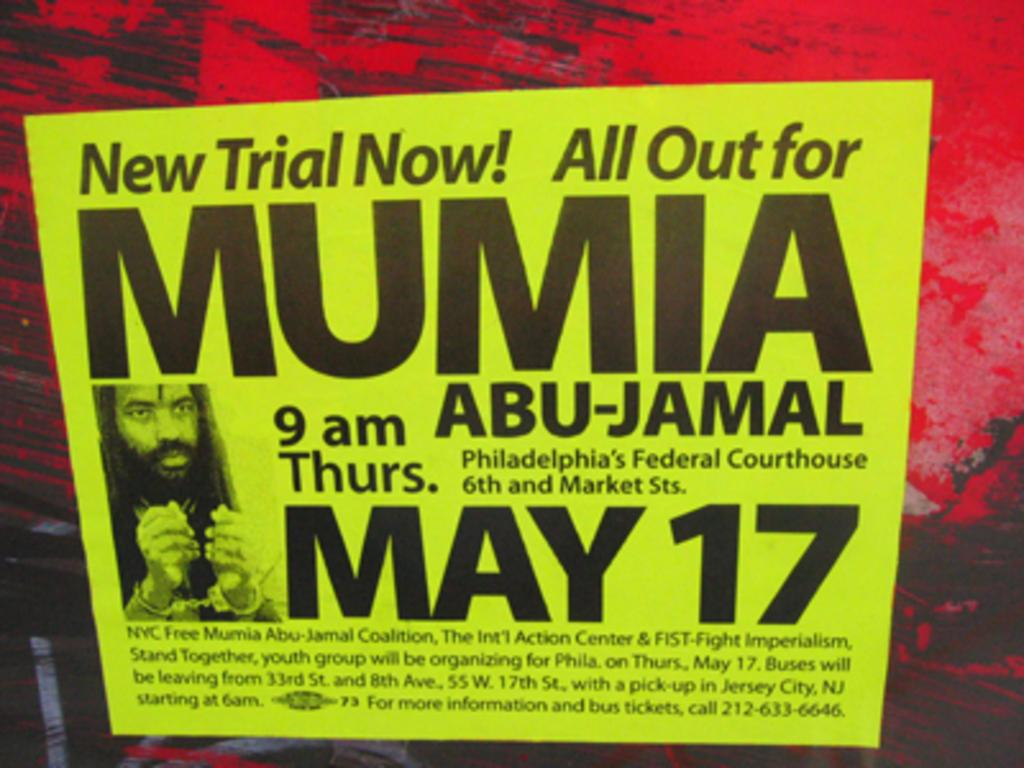<image>
Summarize the visual content of the image. A sign stating New Trial Now with the date of May 17. 